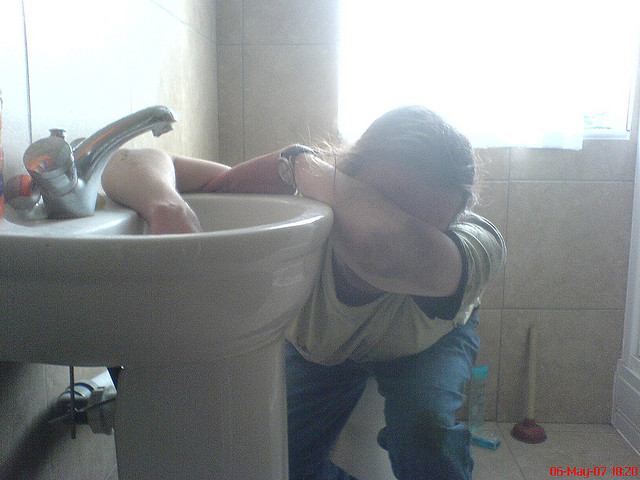Identify and read out the text in this image. 06 May 07 18 20 